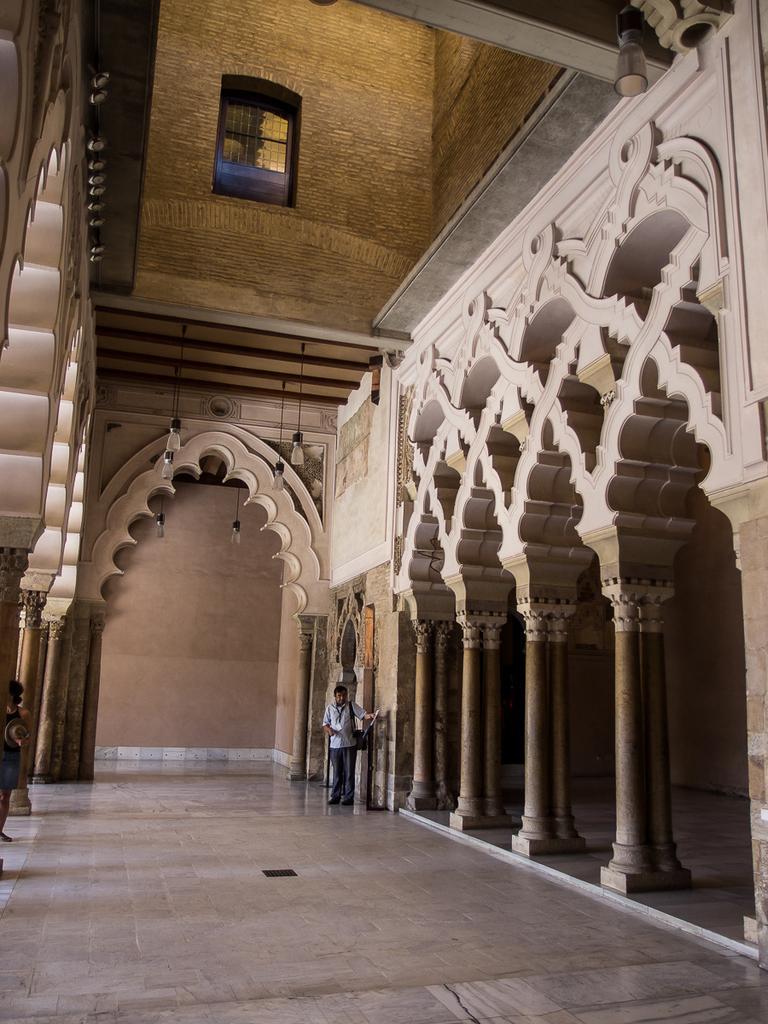Can you describe this image briefly? In this image we can see the inner view of a building, electric lights hanging from the top, windows, person standing on the floor and pillars. 